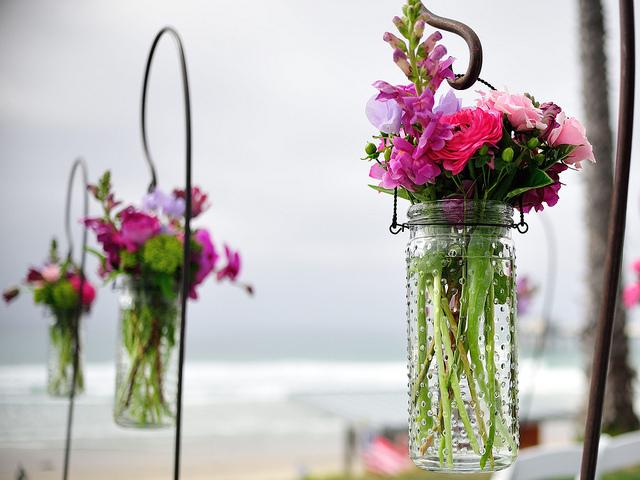What is holding the vases up?
Short answer required. Hangers. Are all the flower vases hanging?
Write a very short answer. Yes. Are the flowers artificial?
Give a very brief answer. No. 